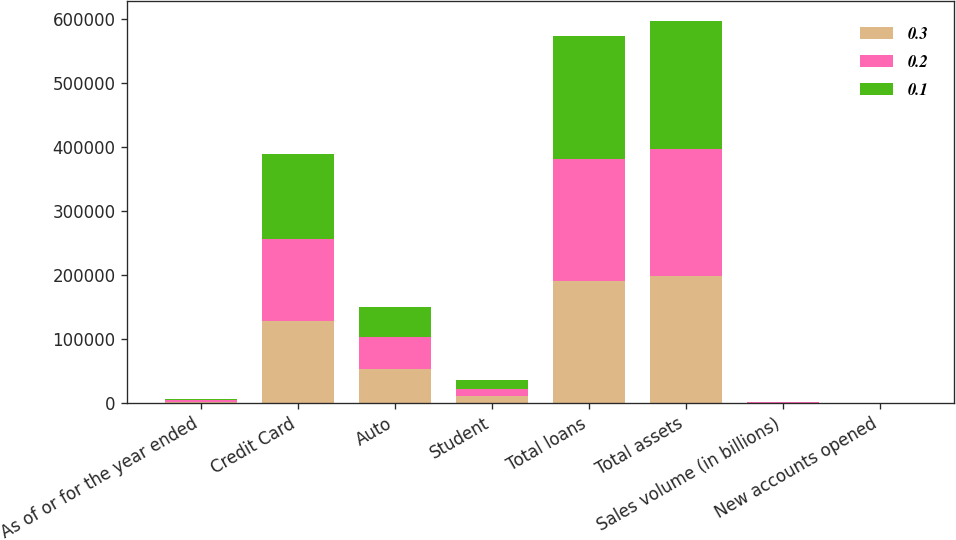<chart> <loc_0><loc_0><loc_500><loc_500><stacked_bar_chart><ecel><fcel>As of or for the year ended<fcel>Credit Card<fcel>Auto<fcel>Student<fcel>Total loans<fcel>Total assets<fcel>Sales volume (in billions)<fcel>New accounts opened<nl><fcel>0.3<fcel>2013<fcel>127791<fcel>52757<fcel>10541<fcel>191089<fcel>198265<fcel>419.5<fcel>7.3<nl><fcel>0.2<fcel>2012<fcel>127993<fcel>49913<fcel>11558<fcel>189464<fcel>197661<fcel>381.1<fcel>6.7<nl><fcel>0.1<fcel>2011<fcel>132277<fcel>47426<fcel>13425<fcel>193128<fcel>201162<fcel>343.7<fcel>8.8<nl></chart> 